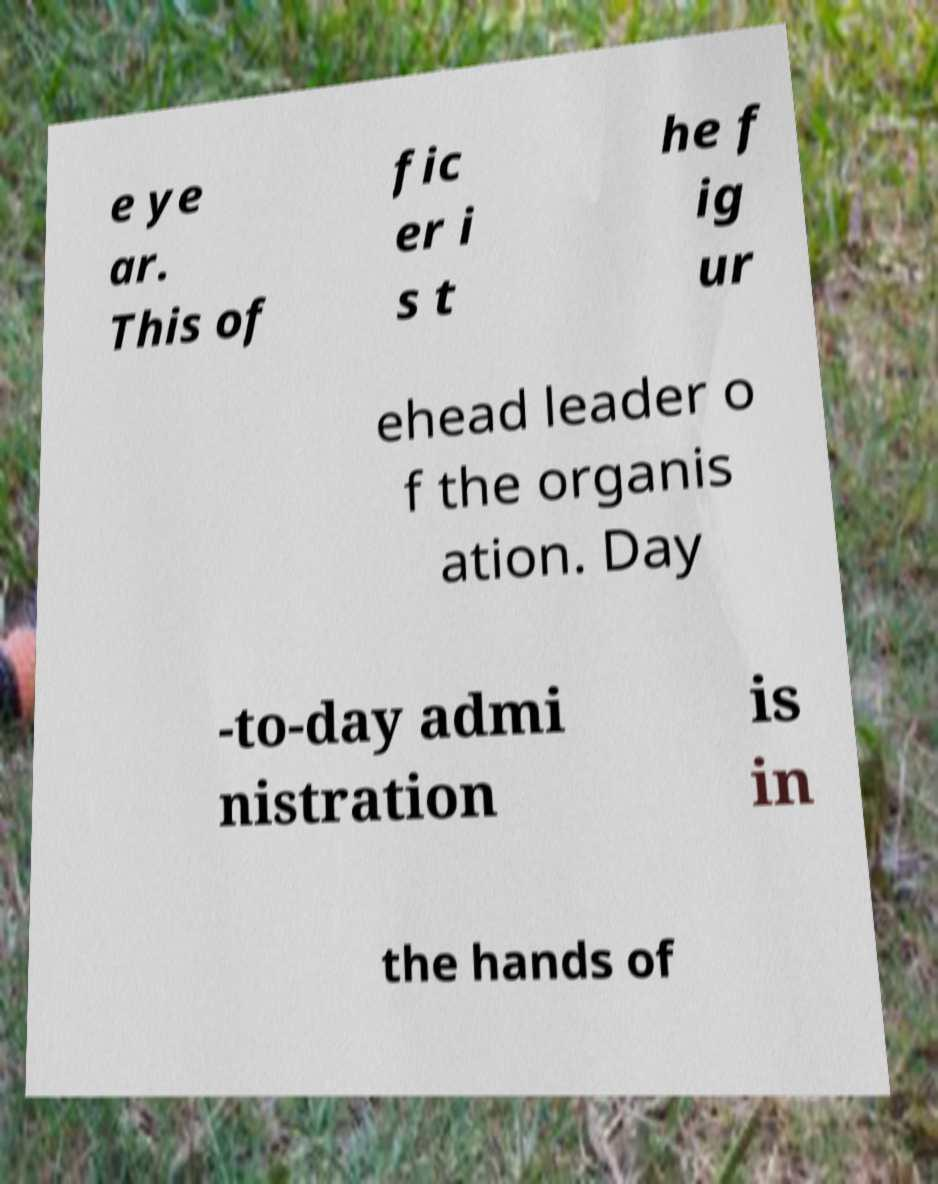Can you accurately transcribe the text from the provided image for me? e ye ar. This of fic er i s t he f ig ur ehead leader o f the organis ation. Day -to-day admi nistration is in the hands of 